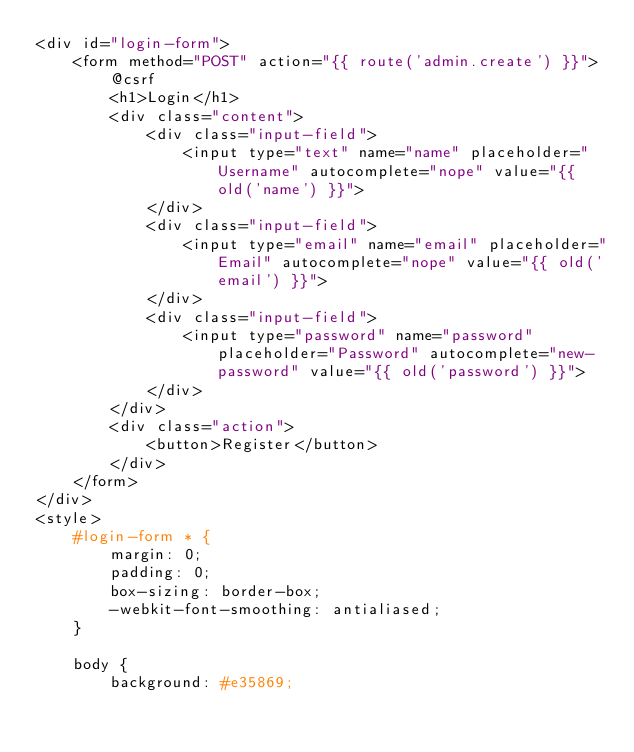Convert code to text. <code><loc_0><loc_0><loc_500><loc_500><_PHP_><div id="login-form">
    <form method="POST" action="{{ route('admin.create') }}">
        @csrf
        <h1>Login</h1>
        <div class="content">
            <div class="input-field">
                <input type="text" name="name" placeholder="Username" autocomplete="nope" value="{{ old('name') }}">
            </div>
            <div class="input-field">
                <input type="email" name="email" placeholder="Email" autocomplete="nope" value="{{ old('email') }}">
            </div>
            <div class="input-field">
                <input type="password" name="password" placeholder="Password" autocomplete="new-password" value="{{ old('password') }}">
            </div>
        </div>
        <div class="action">
            <button>Register</button>
        </div>
    </form>
</div>
<style>
    #login-form * {
        margin: 0;
        padding: 0;
        box-sizing: border-box;
        -webkit-font-smoothing: antialiased;
    }

    body {
        background: #e35869;</code> 